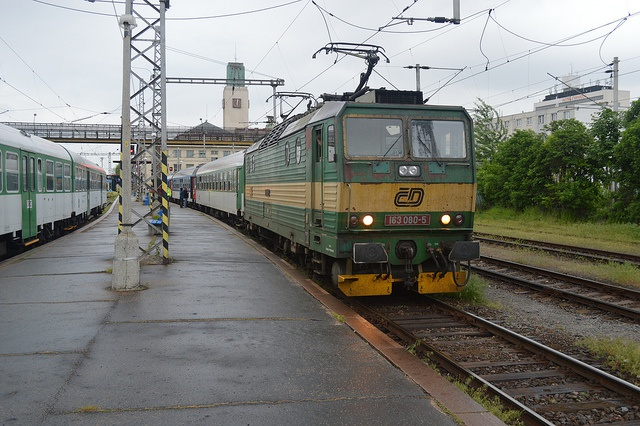Describe the objects in this image and their specific colors. I can see train in lightgray, black, gray, darkgray, and olive tones, train in lightgray, darkgray, gray, and black tones, people in lightgray, black, gray, and blue tones, clock in lightgray, gray, and darkgray tones, and clock in lightgray, gray, and darkgray tones in this image. 